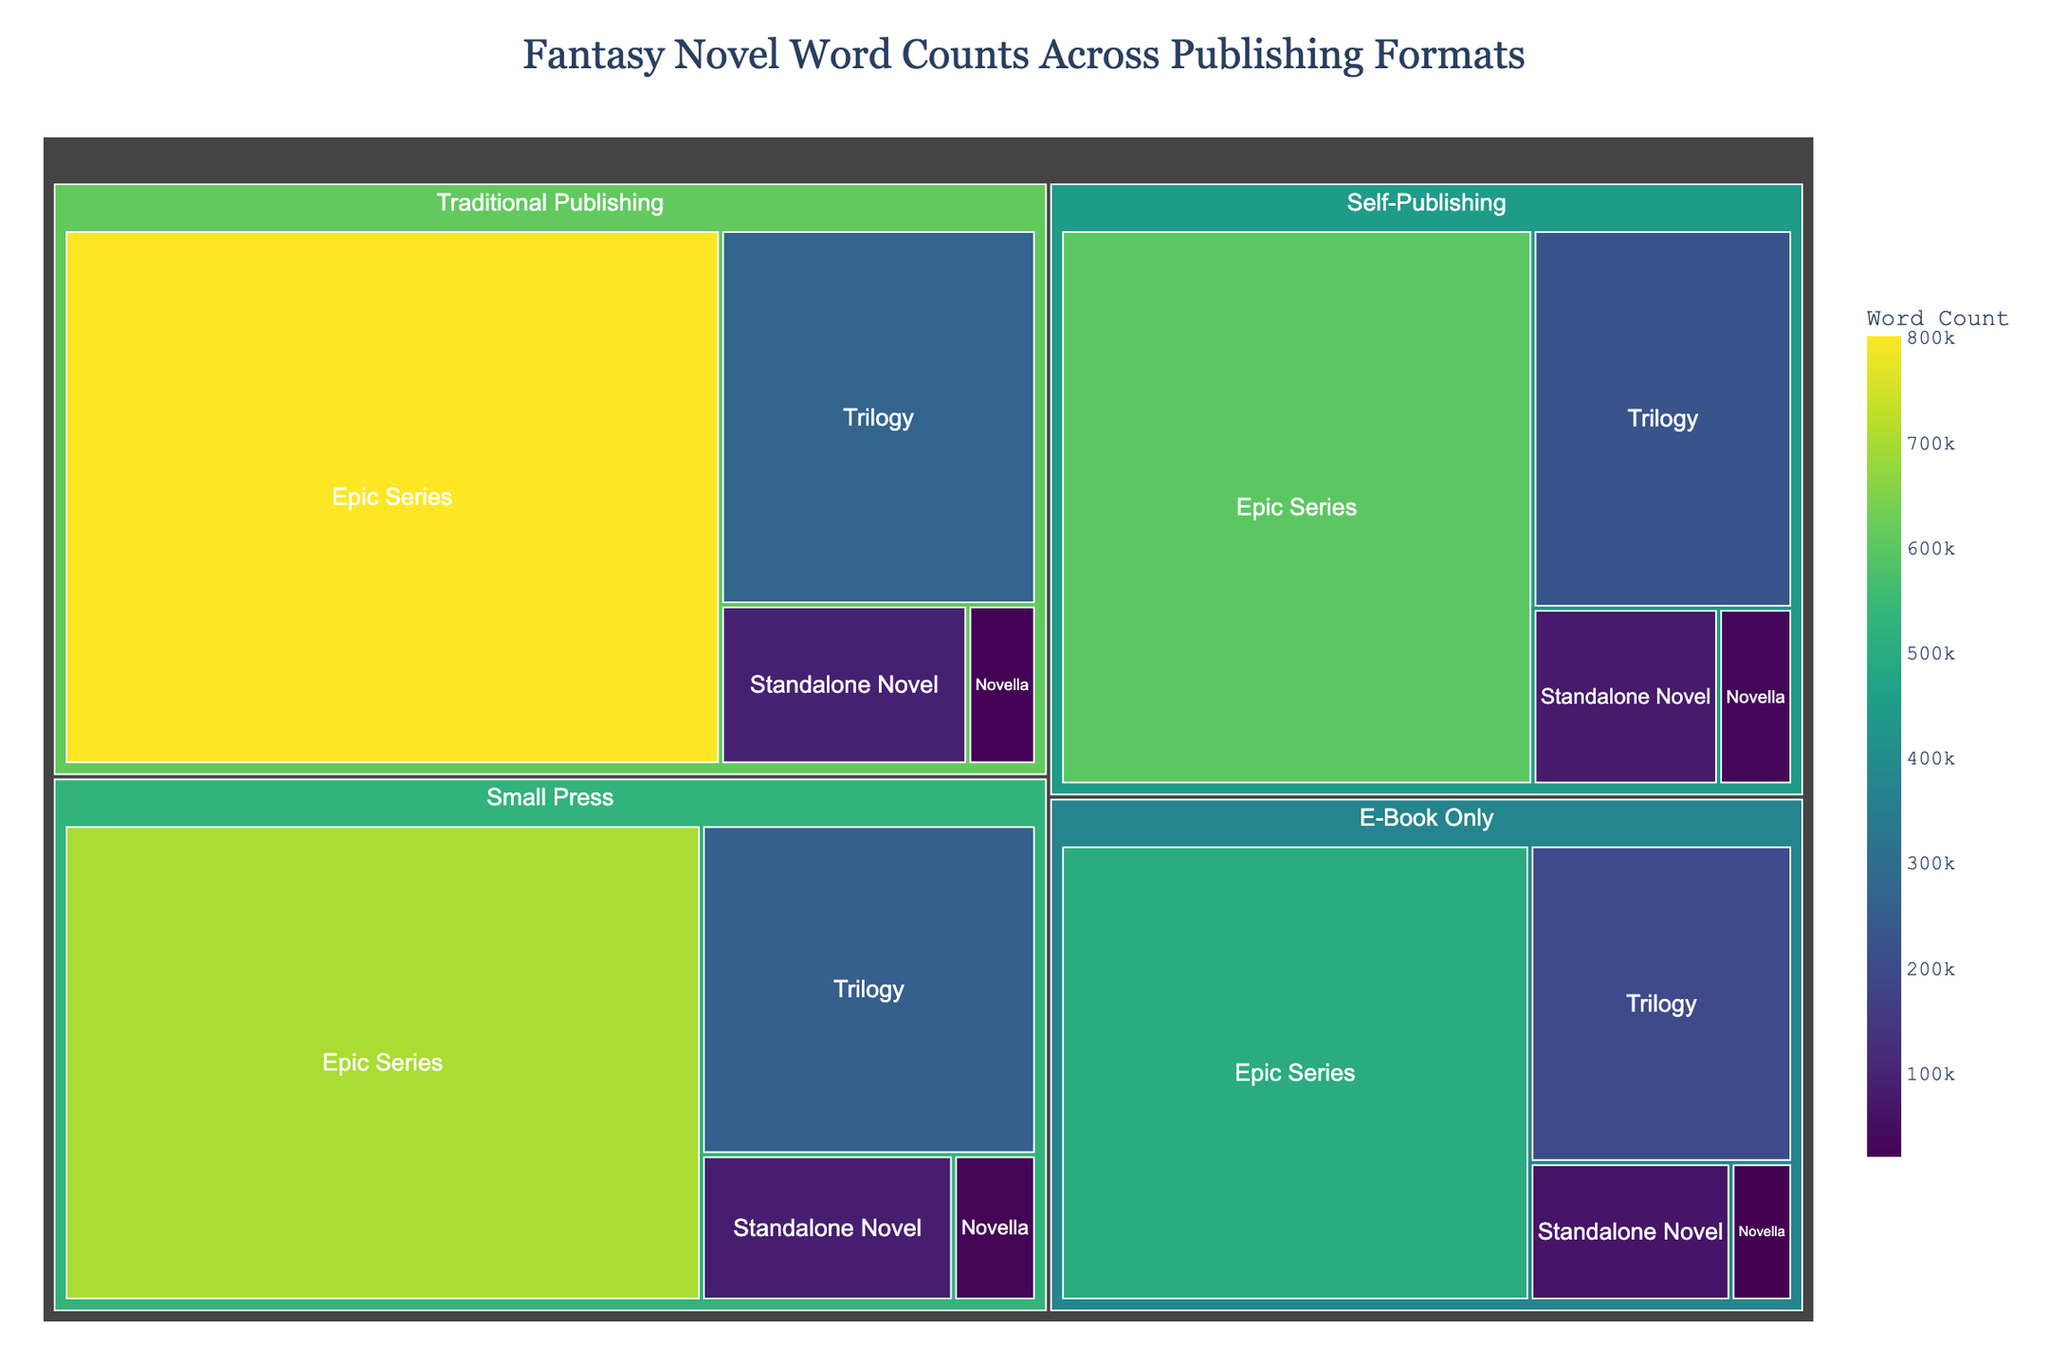What format has the highest total word count in epic series? Identify the sections corresponding to each format's epic series and compare their word counts; the highest is Traditional Publishing with 800,000.
Answer: Traditional Publishing Comparing standalone novels, which publishing format has the least word count? Look at all sections for standalone novels and compare their word counts; the lowest is in E-Book Only with 65,000.
Answer: E-Book Only What's the combined word count for all novellas across all formats? Add up all the word counts in the novella subformat: 25,000 (Traditional Publishing) + 30,000 (Self-Publishing) + 20,000 (E-Book Only) + 28,000 (Small Press) = 103,000.
Answer: 103,000 Which subformat has the overall largest total word count? Compare the total word counts of each subformat across all formats and find the subformat with the highest value; Epic Series is the largest.
Answer: Epic Series In terms of word count, how does the total for Traditional Publishing's trilogy compare to Self-Publishing's trilogy? Identify the word counts for the trilogy in Traditional Publishing and Self-Publishing. Traditional Publishing has 270,000 while Self-Publishing has 225,000, so Traditional Publishing is higher by 45,000.
Answer: Traditional Publishing is higher by 45,000 How many formats have a higher word count for standalone novels than novellas? Compare the word counts for standalone novels and novellas in each format. Traditional Publishing, Small Press, and E-Book Only have higher standalone novel word counts.
Answer: 3 formats What is the average word count for epic series across all formats? Add up the word counts for epic series in all formats and divide by the number of formats: (800,000 + 600,000 + 500,000 + 700,000) / 4 = 2,600,000 / 4 = 650,000.
Answer: 650,000 Which publishing format has the most even distribution of word counts across all subformats? Look for the format where the word counts don't vary drastically; Self-Publishing has relatively even word counts (30,000 to 600,000).
Answer: Self-Publishing Which format has the greatest range in word counts between its smallest and largest subformat? Calculate the range for each format and compare; Traditional Publishing ranges from 25,000 to 800,000, giving a range of 775,000 - the highest.
Answer: Traditional Publishing True or False: The word count for E-Book Only's trilogy is higher than Small Press's trilogy. Compare the word counts directly; 195,000 for E-Book Only vs 255,000 for Small Press; hence the statement is false.
Answer: False 